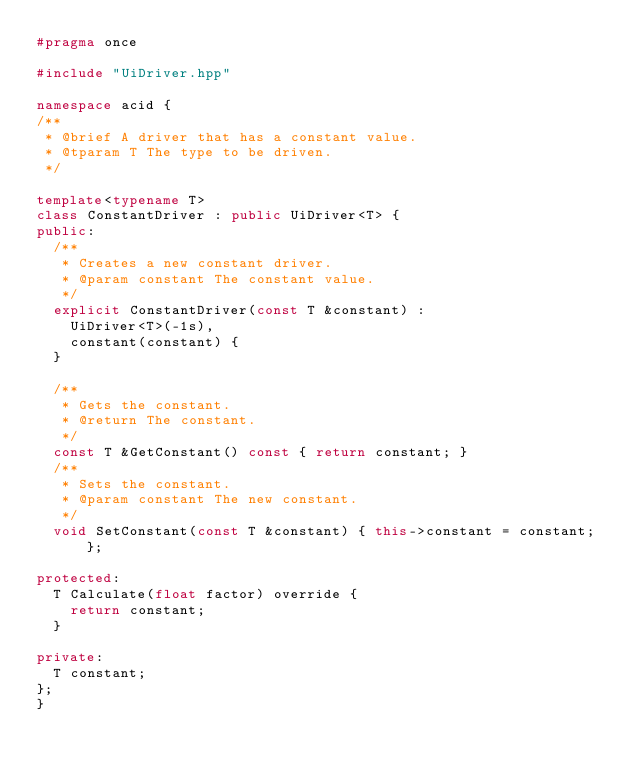Convert code to text. <code><loc_0><loc_0><loc_500><loc_500><_C++_>#pragma once

#include "UiDriver.hpp"

namespace acid {
/**
 * @brief A driver that has a constant value.
 * @tparam T The type to be driven.
 */

template<typename T>
class ConstantDriver : public UiDriver<T> {
public:
	/**
	 * Creates a new constant driver.
	 * @param constant The constant value.
	 */
	explicit ConstantDriver(const T &constant) :
		UiDriver<T>(-1s),
		constant(constant) {
	}

	/**
	 * Gets the constant.
	 * @return The constant.
	 */
	const T &GetConstant() const { return constant; }
	/**
	 * Sets the constant.
	 * @param constant The new constant.
	 */
	void SetConstant(const T &constant) { this->constant = constant; };
	
protected:
	T Calculate(float factor) override {
		return constant;
	}

private:
	T constant;
};
}
</code> 